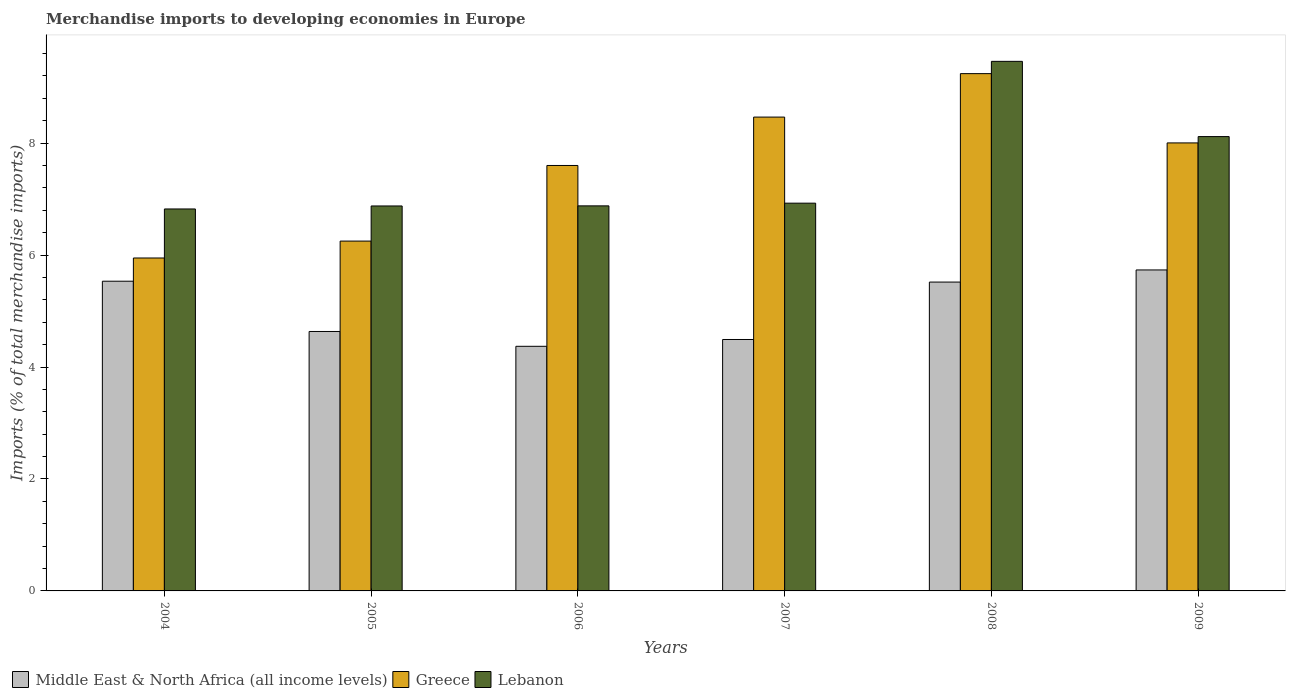Are the number of bars per tick equal to the number of legend labels?
Provide a short and direct response. Yes. In how many cases, is the number of bars for a given year not equal to the number of legend labels?
Make the answer very short. 0. What is the percentage total merchandise imports in Greece in 2005?
Make the answer very short. 6.25. Across all years, what is the maximum percentage total merchandise imports in Middle East & North Africa (all income levels)?
Your answer should be compact. 5.73. Across all years, what is the minimum percentage total merchandise imports in Greece?
Ensure brevity in your answer.  5.95. In which year was the percentage total merchandise imports in Lebanon maximum?
Provide a short and direct response. 2008. What is the total percentage total merchandise imports in Greece in the graph?
Keep it short and to the point. 45.51. What is the difference between the percentage total merchandise imports in Greece in 2004 and that in 2005?
Your answer should be compact. -0.3. What is the difference between the percentage total merchandise imports in Lebanon in 2008 and the percentage total merchandise imports in Greece in 2005?
Make the answer very short. 3.21. What is the average percentage total merchandise imports in Lebanon per year?
Keep it short and to the point. 7.51. In the year 2004, what is the difference between the percentage total merchandise imports in Greece and percentage total merchandise imports in Lebanon?
Offer a very short reply. -0.88. In how many years, is the percentage total merchandise imports in Middle East & North Africa (all income levels) greater than 6 %?
Ensure brevity in your answer.  0. What is the ratio of the percentage total merchandise imports in Lebanon in 2004 to that in 2007?
Ensure brevity in your answer.  0.99. Is the difference between the percentage total merchandise imports in Greece in 2008 and 2009 greater than the difference between the percentage total merchandise imports in Lebanon in 2008 and 2009?
Provide a succinct answer. No. What is the difference between the highest and the second highest percentage total merchandise imports in Middle East & North Africa (all income levels)?
Give a very brief answer. 0.2. What is the difference between the highest and the lowest percentage total merchandise imports in Lebanon?
Give a very brief answer. 2.64. Is the sum of the percentage total merchandise imports in Middle East & North Africa (all income levels) in 2004 and 2006 greater than the maximum percentage total merchandise imports in Greece across all years?
Give a very brief answer. Yes. What does the 3rd bar from the left in 2008 represents?
Your answer should be compact. Lebanon. What does the 1st bar from the right in 2007 represents?
Provide a short and direct response. Lebanon. How many bars are there?
Your response must be concise. 18. Are all the bars in the graph horizontal?
Ensure brevity in your answer.  No. How many years are there in the graph?
Keep it short and to the point. 6. What is the difference between two consecutive major ticks on the Y-axis?
Provide a succinct answer. 2. Does the graph contain any zero values?
Provide a short and direct response. No. How many legend labels are there?
Your answer should be very brief. 3. What is the title of the graph?
Offer a terse response. Merchandise imports to developing economies in Europe. Does "Niger" appear as one of the legend labels in the graph?
Keep it short and to the point. No. What is the label or title of the X-axis?
Provide a succinct answer. Years. What is the label or title of the Y-axis?
Your response must be concise. Imports (% of total merchandise imports). What is the Imports (% of total merchandise imports) of Middle East & North Africa (all income levels) in 2004?
Ensure brevity in your answer.  5.53. What is the Imports (% of total merchandise imports) of Greece in 2004?
Provide a succinct answer. 5.95. What is the Imports (% of total merchandise imports) of Lebanon in 2004?
Your response must be concise. 6.82. What is the Imports (% of total merchandise imports) in Middle East & North Africa (all income levels) in 2005?
Make the answer very short. 4.64. What is the Imports (% of total merchandise imports) in Greece in 2005?
Your response must be concise. 6.25. What is the Imports (% of total merchandise imports) in Lebanon in 2005?
Your response must be concise. 6.88. What is the Imports (% of total merchandise imports) of Middle East & North Africa (all income levels) in 2006?
Provide a succinct answer. 4.37. What is the Imports (% of total merchandise imports) in Greece in 2006?
Keep it short and to the point. 7.6. What is the Imports (% of total merchandise imports) of Lebanon in 2006?
Give a very brief answer. 6.88. What is the Imports (% of total merchandise imports) of Middle East & North Africa (all income levels) in 2007?
Give a very brief answer. 4.49. What is the Imports (% of total merchandise imports) in Greece in 2007?
Make the answer very short. 8.47. What is the Imports (% of total merchandise imports) in Lebanon in 2007?
Give a very brief answer. 6.93. What is the Imports (% of total merchandise imports) of Middle East & North Africa (all income levels) in 2008?
Ensure brevity in your answer.  5.52. What is the Imports (% of total merchandise imports) of Greece in 2008?
Provide a succinct answer. 9.24. What is the Imports (% of total merchandise imports) in Lebanon in 2008?
Your response must be concise. 9.46. What is the Imports (% of total merchandise imports) of Middle East & North Africa (all income levels) in 2009?
Make the answer very short. 5.73. What is the Imports (% of total merchandise imports) of Greece in 2009?
Keep it short and to the point. 8. What is the Imports (% of total merchandise imports) of Lebanon in 2009?
Your answer should be very brief. 8.12. Across all years, what is the maximum Imports (% of total merchandise imports) in Middle East & North Africa (all income levels)?
Make the answer very short. 5.73. Across all years, what is the maximum Imports (% of total merchandise imports) of Greece?
Offer a very short reply. 9.24. Across all years, what is the maximum Imports (% of total merchandise imports) in Lebanon?
Keep it short and to the point. 9.46. Across all years, what is the minimum Imports (% of total merchandise imports) in Middle East & North Africa (all income levels)?
Your response must be concise. 4.37. Across all years, what is the minimum Imports (% of total merchandise imports) of Greece?
Ensure brevity in your answer.  5.95. Across all years, what is the minimum Imports (% of total merchandise imports) in Lebanon?
Make the answer very short. 6.82. What is the total Imports (% of total merchandise imports) in Middle East & North Africa (all income levels) in the graph?
Your answer should be compact. 30.28. What is the total Imports (% of total merchandise imports) in Greece in the graph?
Your answer should be compact. 45.51. What is the total Imports (% of total merchandise imports) in Lebanon in the graph?
Offer a terse response. 45.09. What is the difference between the Imports (% of total merchandise imports) of Middle East & North Africa (all income levels) in 2004 and that in 2005?
Give a very brief answer. 0.9. What is the difference between the Imports (% of total merchandise imports) in Greece in 2004 and that in 2005?
Your response must be concise. -0.3. What is the difference between the Imports (% of total merchandise imports) of Lebanon in 2004 and that in 2005?
Provide a succinct answer. -0.05. What is the difference between the Imports (% of total merchandise imports) in Middle East & North Africa (all income levels) in 2004 and that in 2006?
Your response must be concise. 1.16. What is the difference between the Imports (% of total merchandise imports) in Greece in 2004 and that in 2006?
Your answer should be very brief. -1.65. What is the difference between the Imports (% of total merchandise imports) of Lebanon in 2004 and that in 2006?
Give a very brief answer. -0.06. What is the difference between the Imports (% of total merchandise imports) in Middle East & North Africa (all income levels) in 2004 and that in 2007?
Provide a succinct answer. 1.04. What is the difference between the Imports (% of total merchandise imports) of Greece in 2004 and that in 2007?
Provide a succinct answer. -2.52. What is the difference between the Imports (% of total merchandise imports) of Lebanon in 2004 and that in 2007?
Keep it short and to the point. -0.1. What is the difference between the Imports (% of total merchandise imports) in Middle East & North Africa (all income levels) in 2004 and that in 2008?
Keep it short and to the point. 0.02. What is the difference between the Imports (% of total merchandise imports) in Greece in 2004 and that in 2008?
Make the answer very short. -3.29. What is the difference between the Imports (% of total merchandise imports) of Lebanon in 2004 and that in 2008?
Make the answer very short. -2.64. What is the difference between the Imports (% of total merchandise imports) of Middle East & North Africa (all income levels) in 2004 and that in 2009?
Offer a very short reply. -0.2. What is the difference between the Imports (% of total merchandise imports) of Greece in 2004 and that in 2009?
Your answer should be very brief. -2.06. What is the difference between the Imports (% of total merchandise imports) of Lebanon in 2004 and that in 2009?
Make the answer very short. -1.29. What is the difference between the Imports (% of total merchandise imports) of Middle East & North Africa (all income levels) in 2005 and that in 2006?
Offer a terse response. 0.26. What is the difference between the Imports (% of total merchandise imports) of Greece in 2005 and that in 2006?
Your answer should be very brief. -1.35. What is the difference between the Imports (% of total merchandise imports) in Lebanon in 2005 and that in 2006?
Give a very brief answer. -0. What is the difference between the Imports (% of total merchandise imports) in Middle East & North Africa (all income levels) in 2005 and that in 2007?
Give a very brief answer. 0.14. What is the difference between the Imports (% of total merchandise imports) of Greece in 2005 and that in 2007?
Make the answer very short. -2.22. What is the difference between the Imports (% of total merchandise imports) of Lebanon in 2005 and that in 2007?
Offer a terse response. -0.05. What is the difference between the Imports (% of total merchandise imports) in Middle East & North Africa (all income levels) in 2005 and that in 2008?
Offer a terse response. -0.88. What is the difference between the Imports (% of total merchandise imports) of Greece in 2005 and that in 2008?
Provide a short and direct response. -2.99. What is the difference between the Imports (% of total merchandise imports) in Lebanon in 2005 and that in 2008?
Ensure brevity in your answer.  -2.58. What is the difference between the Imports (% of total merchandise imports) in Middle East & North Africa (all income levels) in 2005 and that in 2009?
Offer a terse response. -1.1. What is the difference between the Imports (% of total merchandise imports) in Greece in 2005 and that in 2009?
Your answer should be compact. -1.75. What is the difference between the Imports (% of total merchandise imports) in Lebanon in 2005 and that in 2009?
Your answer should be compact. -1.24. What is the difference between the Imports (% of total merchandise imports) in Middle East & North Africa (all income levels) in 2006 and that in 2007?
Offer a very short reply. -0.12. What is the difference between the Imports (% of total merchandise imports) of Greece in 2006 and that in 2007?
Your answer should be compact. -0.86. What is the difference between the Imports (% of total merchandise imports) of Lebanon in 2006 and that in 2007?
Offer a terse response. -0.05. What is the difference between the Imports (% of total merchandise imports) in Middle East & North Africa (all income levels) in 2006 and that in 2008?
Make the answer very short. -1.15. What is the difference between the Imports (% of total merchandise imports) in Greece in 2006 and that in 2008?
Keep it short and to the point. -1.64. What is the difference between the Imports (% of total merchandise imports) of Lebanon in 2006 and that in 2008?
Your response must be concise. -2.58. What is the difference between the Imports (% of total merchandise imports) in Middle East & North Africa (all income levels) in 2006 and that in 2009?
Your answer should be compact. -1.36. What is the difference between the Imports (% of total merchandise imports) in Greece in 2006 and that in 2009?
Ensure brevity in your answer.  -0.4. What is the difference between the Imports (% of total merchandise imports) of Lebanon in 2006 and that in 2009?
Give a very brief answer. -1.24. What is the difference between the Imports (% of total merchandise imports) in Middle East & North Africa (all income levels) in 2007 and that in 2008?
Your answer should be very brief. -1.03. What is the difference between the Imports (% of total merchandise imports) of Greece in 2007 and that in 2008?
Ensure brevity in your answer.  -0.78. What is the difference between the Imports (% of total merchandise imports) in Lebanon in 2007 and that in 2008?
Ensure brevity in your answer.  -2.53. What is the difference between the Imports (% of total merchandise imports) in Middle East & North Africa (all income levels) in 2007 and that in 2009?
Provide a short and direct response. -1.24. What is the difference between the Imports (% of total merchandise imports) of Greece in 2007 and that in 2009?
Offer a terse response. 0.46. What is the difference between the Imports (% of total merchandise imports) in Lebanon in 2007 and that in 2009?
Keep it short and to the point. -1.19. What is the difference between the Imports (% of total merchandise imports) in Middle East & North Africa (all income levels) in 2008 and that in 2009?
Ensure brevity in your answer.  -0.22. What is the difference between the Imports (% of total merchandise imports) of Greece in 2008 and that in 2009?
Your answer should be very brief. 1.24. What is the difference between the Imports (% of total merchandise imports) in Lebanon in 2008 and that in 2009?
Provide a succinct answer. 1.34. What is the difference between the Imports (% of total merchandise imports) of Middle East & North Africa (all income levels) in 2004 and the Imports (% of total merchandise imports) of Greece in 2005?
Offer a very short reply. -0.72. What is the difference between the Imports (% of total merchandise imports) in Middle East & North Africa (all income levels) in 2004 and the Imports (% of total merchandise imports) in Lebanon in 2005?
Provide a succinct answer. -1.34. What is the difference between the Imports (% of total merchandise imports) in Greece in 2004 and the Imports (% of total merchandise imports) in Lebanon in 2005?
Give a very brief answer. -0.93. What is the difference between the Imports (% of total merchandise imports) in Middle East & North Africa (all income levels) in 2004 and the Imports (% of total merchandise imports) in Greece in 2006?
Your answer should be very brief. -2.07. What is the difference between the Imports (% of total merchandise imports) of Middle East & North Africa (all income levels) in 2004 and the Imports (% of total merchandise imports) of Lebanon in 2006?
Provide a succinct answer. -1.35. What is the difference between the Imports (% of total merchandise imports) of Greece in 2004 and the Imports (% of total merchandise imports) of Lebanon in 2006?
Keep it short and to the point. -0.93. What is the difference between the Imports (% of total merchandise imports) in Middle East & North Africa (all income levels) in 2004 and the Imports (% of total merchandise imports) in Greece in 2007?
Ensure brevity in your answer.  -2.93. What is the difference between the Imports (% of total merchandise imports) in Middle East & North Africa (all income levels) in 2004 and the Imports (% of total merchandise imports) in Lebanon in 2007?
Keep it short and to the point. -1.39. What is the difference between the Imports (% of total merchandise imports) in Greece in 2004 and the Imports (% of total merchandise imports) in Lebanon in 2007?
Offer a very short reply. -0.98. What is the difference between the Imports (% of total merchandise imports) of Middle East & North Africa (all income levels) in 2004 and the Imports (% of total merchandise imports) of Greece in 2008?
Provide a succinct answer. -3.71. What is the difference between the Imports (% of total merchandise imports) in Middle East & North Africa (all income levels) in 2004 and the Imports (% of total merchandise imports) in Lebanon in 2008?
Offer a very short reply. -3.93. What is the difference between the Imports (% of total merchandise imports) in Greece in 2004 and the Imports (% of total merchandise imports) in Lebanon in 2008?
Provide a succinct answer. -3.51. What is the difference between the Imports (% of total merchandise imports) in Middle East & North Africa (all income levels) in 2004 and the Imports (% of total merchandise imports) in Greece in 2009?
Make the answer very short. -2.47. What is the difference between the Imports (% of total merchandise imports) of Middle East & North Africa (all income levels) in 2004 and the Imports (% of total merchandise imports) of Lebanon in 2009?
Ensure brevity in your answer.  -2.58. What is the difference between the Imports (% of total merchandise imports) in Greece in 2004 and the Imports (% of total merchandise imports) in Lebanon in 2009?
Provide a short and direct response. -2.17. What is the difference between the Imports (% of total merchandise imports) of Middle East & North Africa (all income levels) in 2005 and the Imports (% of total merchandise imports) of Greece in 2006?
Keep it short and to the point. -2.97. What is the difference between the Imports (% of total merchandise imports) in Middle East & North Africa (all income levels) in 2005 and the Imports (% of total merchandise imports) in Lebanon in 2006?
Offer a very short reply. -2.24. What is the difference between the Imports (% of total merchandise imports) of Greece in 2005 and the Imports (% of total merchandise imports) of Lebanon in 2006?
Your response must be concise. -0.63. What is the difference between the Imports (% of total merchandise imports) in Middle East & North Africa (all income levels) in 2005 and the Imports (% of total merchandise imports) in Greece in 2007?
Make the answer very short. -3.83. What is the difference between the Imports (% of total merchandise imports) of Middle East & North Africa (all income levels) in 2005 and the Imports (% of total merchandise imports) of Lebanon in 2007?
Offer a terse response. -2.29. What is the difference between the Imports (% of total merchandise imports) in Greece in 2005 and the Imports (% of total merchandise imports) in Lebanon in 2007?
Provide a succinct answer. -0.68. What is the difference between the Imports (% of total merchandise imports) in Middle East & North Africa (all income levels) in 2005 and the Imports (% of total merchandise imports) in Greece in 2008?
Make the answer very short. -4.61. What is the difference between the Imports (% of total merchandise imports) in Middle East & North Africa (all income levels) in 2005 and the Imports (% of total merchandise imports) in Lebanon in 2008?
Offer a terse response. -4.83. What is the difference between the Imports (% of total merchandise imports) in Greece in 2005 and the Imports (% of total merchandise imports) in Lebanon in 2008?
Your answer should be very brief. -3.21. What is the difference between the Imports (% of total merchandise imports) in Middle East & North Africa (all income levels) in 2005 and the Imports (% of total merchandise imports) in Greece in 2009?
Your answer should be very brief. -3.37. What is the difference between the Imports (% of total merchandise imports) of Middle East & North Africa (all income levels) in 2005 and the Imports (% of total merchandise imports) of Lebanon in 2009?
Give a very brief answer. -3.48. What is the difference between the Imports (% of total merchandise imports) of Greece in 2005 and the Imports (% of total merchandise imports) of Lebanon in 2009?
Keep it short and to the point. -1.87. What is the difference between the Imports (% of total merchandise imports) of Middle East & North Africa (all income levels) in 2006 and the Imports (% of total merchandise imports) of Greece in 2007?
Keep it short and to the point. -4.1. What is the difference between the Imports (% of total merchandise imports) in Middle East & North Africa (all income levels) in 2006 and the Imports (% of total merchandise imports) in Lebanon in 2007?
Offer a very short reply. -2.56. What is the difference between the Imports (% of total merchandise imports) in Greece in 2006 and the Imports (% of total merchandise imports) in Lebanon in 2007?
Provide a succinct answer. 0.67. What is the difference between the Imports (% of total merchandise imports) in Middle East & North Africa (all income levels) in 2006 and the Imports (% of total merchandise imports) in Greece in 2008?
Offer a terse response. -4.87. What is the difference between the Imports (% of total merchandise imports) in Middle East & North Africa (all income levels) in 2006 and the Imports (% of total merchandise imports) in Lebanon in 2008?
Give a very brief answer. -5.09. What is the difference between the Imports (% of total merchandise imports) in Greece in 2006 and the Imports (% of total merchandise imports) in Lebanon in 2008?
Provide a short and direct response. -1.86. What is the difference between the Imports (% of total merchandise imports) of Middle East & North Africa (all income levels) in 2006 and the Imports (% of total merchandise imports) of Greece in 2009?
Your answer should be compact. -3.63. What is the difference between the Imports (% of total merchandise imports) in Middle East & North Africa (all income levels) in 2006 and the Imports (% of total merchandise imports) in Lebanon in 2009?
Keep it short and to the point. -3.75. What is the difference between the Imports (% of total merchandise imports) in Greece in 2006 and the Imports (% of total merchandise imports) in Lebanon in 2009?
Ensure brevity in your answer.  -0.52. What is the difference between the Imports (% of total merchandise imports) in Middle East & North Africa (all income levels) in 2007 and the Imports (% of total merchandise imports) in Greece in 2008?
Ensure brevity in your answer.  -4.75. What is the difference between the Imports (% of total merchandise imports) in Middle East & North Africa (all income levels) in 2007 and the Imports (% of total merchandise imports) in Lebanon in 2008?
Your answer should be compact. -4.97. What is the difference between the Imports (% of total merchandise imports) in Greece in 2007 and the Imports (% of total merchandise imports) in Lebanon in 2008?
Ensure brevity in your answer.  -1. What is the difference between the Imports (% of total merchandise imports) of Middle East & North Africa (all income levels) in 2007 and the Imports (% of total merchandise imports) of Greece in 2009?
Ensure brevity in your answer.  -3.51. What is the difference between the Imports (% of total merchandise imports) of Middle East & North Africa (all income levels) in 2007 and the Imports (% of total merchandise imports) of Lebanon in 2009?
Offer a terse response. -3.63. What is the difference between the Imports (% of total merchandise imports) in Greece in 2007 and the Imports (% of total merchandise imports) in Lebanon in 2009?
Make the answer very short. 0.35. What is the difference between the Imports (% of total merchandise imports) of Middle East & North Africa (all income levels) in 2008 and the Imports (% of total merchandise imports) of Greece in 2009?
Your answer should be compact. -2.49. What is the difference between the Imports (% of total merchandise imports) in Middle East & North Africa (all income levels) in 2008 and the Imports (% of total merchandise imports) in Lebanon in 2009?
Your answer should be very brief. -2.6. What is the difference between the Imports (% of total merchandise imports) of Greece in 2008 and the Imports (% of total merchandise imports) of Lebanon in 2009?
Your answer should be compact. 1.12. What is the average Imports (% of total merchandise imports) in Middle East & North Africa (all income levels) per year?
Provide a succinct answer. 5.05. What is the average Imports (% of total merchandise imports) of Greece per year?
Offer a terse response. 7.59. What is the average Imports (% of total merchandise imports) in Lebanon per year?
Give a very brief answer. 7.51. In the year 2004, what is the difference between the Imports (% of total merchandise imports) of Middle East & North Africa (all income levels) and Imports (% of total merchandise imports) of Greece?
Keep it short and to the point. -0.41. In the year 2004, what is the difference between the Imports (% of total merchandise imports) in Middle East & North Africa (all income levels) and Imports (% of total merchandise imports) in Lebanon?
Keep it short and to the point. -1.29. In the year 2004, what is the difference between the Imports (% of total merchandise imports) in Greece and Imports (% of total merchandise imports) in Lebanon?
Your response must be concise. -0.88. In the year 2005, what is the difference between the Imports (% of total merchandise imports) in Middle East & North Africa (all income levels) and Imports (% of total merchandise imports) in Greece?
Keep it short and to the point. -1.61. In the year 2005, what is the difference between the Imports (% of total merchandise imports) of Middle East & North Africa (all income levels) and Imports (% of total merchandise imports) of Lebanon?
Your answer should be compact. -2.24. In the year 2005, what is the difference between the Imports (% of total merchandise imports) in Greece and Imports (% of total merchandise imports) in Lebanon?
Offer a very short reply. -0.63. In the year 2006, what is the difference between the Imports (% of total merchandise imports) in Middle East & North Africa (all income levels) and Imports (% of total merchandise imports) in Greece?
Your answer should be very brief. -3.23. In the year 2006, what is the difference between the Imports (% of total merchandise imports) of Middle East & North Africa (all income levels) and Imports (% of total merchandise imports) of Lebanon?
Your answer should be very brief. -2.51. In the year 2006, what is the difference between the Imports (% of total merchandise imports) of Greece and Imports (% of total merchandise imports) of Lebanon?
Offer a terse response. 0.72. In the year 2007, what is the difference between the Imports (% of total merchandise imports) of Middle East & North Africa (all income levels) and Imports (% of total merchandise imports) of Greece?
Ensure brevity in your answer.  -3.97. In the year 2007, what is the difference between the Imports (% of total merchandise imports) of Middle East & North Africa (all income levels) and Imports (% of total merchandise imports) of Lebanon?
Keep it short and to the point. -2.44. In the year 2007, what is the difference between the Imports (% of total merchandise imports) in Greece and Imports (% of total merchandise imports) in Lebanon?
Your answer should be very brief. 1.54. In the year 2008, what is the difference between the Imports (% of total merchandise imports) in Middle East & North Africa (all income levels) and Imports (% of total merchandise imports) in Greece?
Your answer should be compact. -3.72. In the year 2008, what is the difference between the Imports (% of total merchandise imports) of Middle East & North Africa (all income levels) and Imports (% of total merchandise imports) of Lebanon?
Make the answer very short. -3.94. In the year 2008, what is the difference between the Imports (% of total merchandise imports) of Greece and Imports (% of total merchandise imports) of Lebanon?
Your answer should be very brief. -0.22. In the year 2009, what is the difference between the Imports (% of total merchandise imports) of Middle East & North Africa (all income levels) and Imports (% of total merchandise imports) of Greece?
Offer a very short reply. -2.27. In the year 2009, what is the difference between the Imports (% of total merchandise imports) of Middle East & North Africa (all income levels) and Imports (% of total merchandise imports) of Lebanon?
Your response must be concise. -2.38. In the year 2009, what is the difference between the Imports (% of total merchandise imports) in Greece and Imports (% of total merchandise imports) in Lebanon?
Your response must be concise. -0.11. What is the ratio of the Imports (% of total merchandise imports) in Middle East & North Africa (all income levels) in 2004 to that in 2005?
Give a very brief answer. 1.19. What is the ratio of the Imports (% of total merchandise imports) of Greece in 2004 to that in 2005?
Offer a terse response. 0.95. What is the ratio of the Imports (% of total merchandise imports) of Middle East & North Africa (all income levels) in 2004 to that in 2006?
Your response must be concise. 1.27. What is the ratio of the Imports (% of total merchandise imports) of Greece in 2004 to that in 2006?
Offer a terse response. 0.78. What is the ratio of the Imports (% of total merchandise imports) of Lebanon in 2004 to that in 2006?
Your response must be concise. 0.99. What is the ratio of the Imports (% of total merchandise imports) of Middle East & North Africa (all income levels) in 2004 to that in 2007?
Give a very brief answer. 1.23. What is the ratio of the Imports (% of total merchandise imports) in Greece in 2004 to that in 2007?
Give a very brief answer. 0.7. What is the ratio of the Imports (% of total merchandise imports) in Lebanon in 2004 to that in 2007?
Provide a short and direct response. 0.99. What is the ratio of the Imports (% of total merchandise imports) in Middle East & North Africa (all income levels) in 2004 to that in 2008?
Offer a terse response. 1. What is the ratio of the Imports (% of total merchandise imports) in Greece in 2004 to that in 2008?
Keep it short and to the point. 0.64. What is the ratio of the Imports (% of total merchandise imports) in Lebanon in 2004 to that in 2008?
Ensure brevity in your answer.  0.72. What is the ratio of the Imports (% of total merchandise imports) in Middle East & North Africa (all income levels) in 2004 to that in 2009?
Make the answer very short. 0.96. What is the ratio of the Imports (% of total merchandise imports) of Greece in 2004 to that in 2009?
Offer a terse response. 0.74. What is the ratio of the Imports (% of total merchandise imports) in Lebanon in 2004 to that in 2009?
Your answer should be very brief. 0.84. What is the ratio of the Imports (% of total merchandise imports) of Middle East & North Africa (all income levels) in 2005 to that in 2006?
Provide a succinct answer. 1.06. What is the ratio of the Imports (% of total merchandise imports) in Greece in 2005 to that in 2006?
Give a very brief answer. 0.82. What is the ratio of the Imports (% of total merchandise imports) in Middle East & North Africa (all income levels) in 2005 to that in 2007?
Your response must be concise. 1.03. What is the ratio of the Imports (% of total merchandise imports) in Greece in 2005 to that in 2007?
Offer a very short reply. 0.74. What is the ratio of the Imports (% of total merchandise imports) of Lebanon in 2005 to that in 2007?
Offer a terse response. 0.99. What is the ratio of the Imports (% of total merchandise imports) in Middle East & North Africa (all income levels) in 2005 to that in 2008?
Provide a succinct answer. 0.84. What is the ratio of the Imports (% of total merchandise imports) in Greece in 2005 to that in 2008?
Your answer should be very brief. 0.68. What is the ratio of the Imports (% of total merchandise imports) of Lebanon in 2005 to that in 2008?
Ensure brevity in your answer.  0.73. What is the ratio of the Imports (% of total merchandise imports) of Middle East & North Africa (all income levels) in 2005 to that in 2009?
Keep it short and to the point. 0.81. What is the ratio of the Imports (% of total merchandise imports) of Greece in 2005 to that in 2009?
Provide a short and direct response. 0.78. What is the ratio of the Imports (% of total merchandise imports) of Lebanon in 2005 to that in 2009?
Your answer should be very brief. 0.85. What is the ratio of the Imports (% of total merchandise imports) in Middle East & North Africa (all income levels) in 2006 to that in 2007?
Make the answer very short. 0.97. What is the ratio of the Imports (% of total merchandise imports) in Greece in 2006 to that in 2007?
Provide a short and direct response. 0.9. What is the ratio of the Imports (% of total merchandise imports) of Middle East & North Africa (all income levels) in 2006 to that in 2008?
Keep it short and to the point. 0.79. What is the ratio of the Imports (% of total merchandise imports) in Greece in 2006 to that in 2008?
Provide a short and direct response. 0.82. What is the ratio of the Imports (% of total merchandise imports) of Lebanon in 2006 to that in 2008?
Provide a succinct answer. 0.73. What is the ratio of the Imports (% of total merchandise imports) of Middle East & North Africa (all income levels) in 2006 to that in 2009?
Provide a short and direct response. 0.76. What is the ratio of the Imports (% of total merchandise imports) in Greece in 2006 to that in 2009?
Keep it short and to the point. 0.95. What is the ratio of the Imports (% of total merchandise imports) in Lebanon in 2006 to that in 2009?
Offer a terse response. 0.85. What is the ratio of the Imports (% of total merchandise imports) of Middle East & North Africa (all income levels) in 2007 to that in 2008?
Make the answer very short. 0.81. What is the ratio of the Imports (% of total merchandise imports) of Greece in 2007 to that in 2008?
Your answer should be very brief. 0.92. What is the ratio of the Imports (% of total merchandise imports) of Lebanon in 2007 to that in 2008?
Ensure brevity in your answer.  0.73. What is the ratio of the Imports (% of total merchandise imports) in Middle East & North Africa (all income levels) in 2007 to that in 2009?
Offer a terse response. 0.78. What is the ratio of the Imports (% of total merchandise imports) in Greece in 2007 to that in 2009?
Give a very brief answer. 1.06. What is the ratio of the Imports (% of total merchandise imports) of Lebanon in 2007 to that in 2009?
Keep it short and to the point. 0.85. What is the ratio of the Imports (% of total merchandise imports) of Middle East & North Africa (all income levels) in 2008 to that in 2009?
Make the answer very short. 0.96. What is the ratio of the Imports (% of total merchandise imports) in Greece in 2008 to that in 2009?
Make the answer very short. 1.15. What is the ratio of the Imports (% of total merchandise imports) in Lebanon in 2008 to that in 2009?
Make the answer very short. 1.17. What is the difference between the highest and the second highest Imports (% of total merchandise imports) in Middle East & North Africa (all income levels)?
Make the answer very short. 0.2. What is the difference between the highest and the second highest Imports (% of total merchandise imports) of Greece?
Provide a short and direct response. 0.78. What is the difference between the highest and the second highest Imports (% of total merchandise imports) of Lebanon?
Your response must be concise. 1.34. What is the difference between the highest and the lowest Imports (% of total merchandise imports) in Middle East & North Africa (all income levels)?
Ensure brevity in your answer.  1.36. What is the difference between the highest and the lowest Imports (% of total merchandise imports) of Greece?
Offer a very short reply. 3.29. What is the difference between the highest and the lowest Imports (% of total merchandise imports) in Lebanon?
Provide a succinct answer. 2.64. 